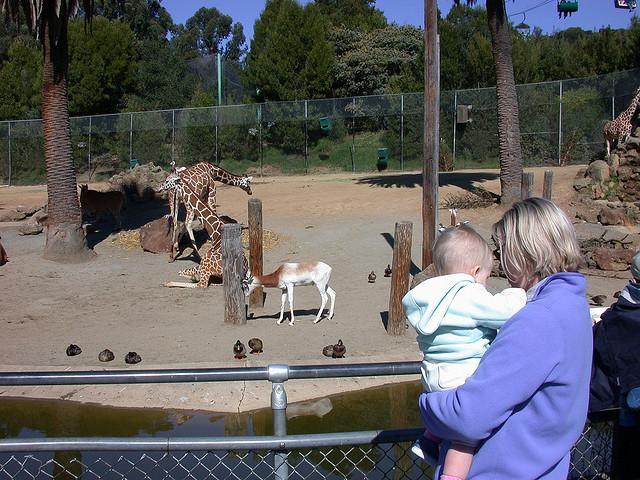What are the birds in the pen called? Please explain your reasoning. ducks. Ducks are usually found by the water. 